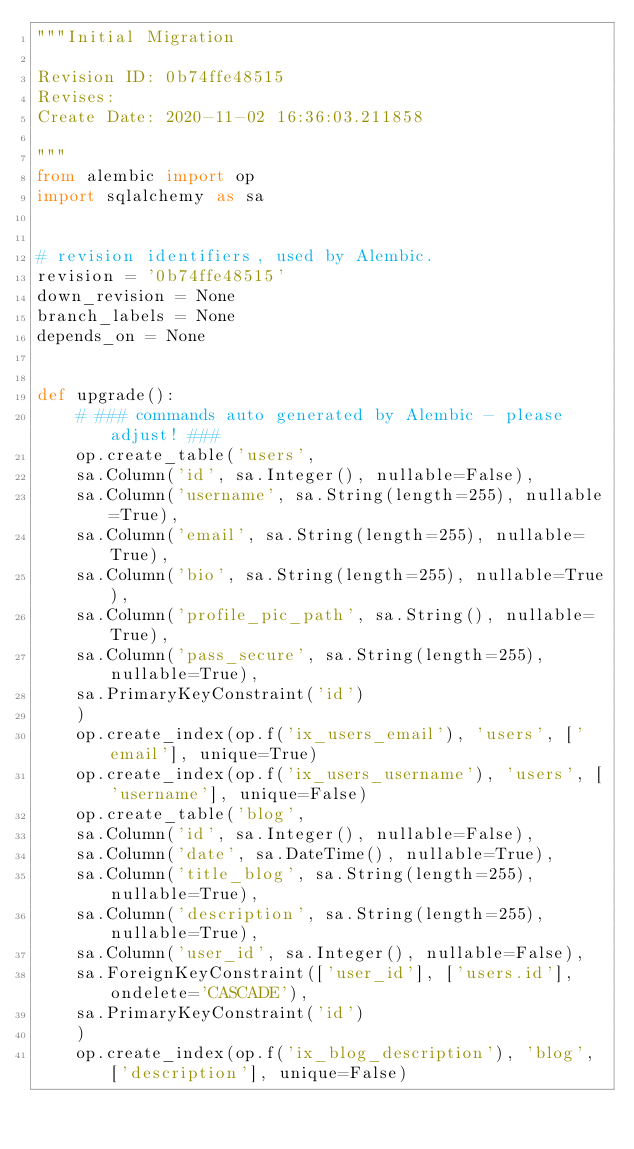<code> <loc_0><loc_0><loc_500><loc_500><_Python_>"""Initial Migration

Revision ID: 0b74ffe48515
Revises: 
Create Date: 2020-11-02 16:36:03.211858

"""
from alembic import op
import sqlalchemy as sa


# revision identifiers, used by Alembic.
revision = '0b74ffe48515'
down_revision = None
branch_labels = None
depends_on = None


def upgrade():
    # ### commands auto generated by Alembic - please adjust! ###
    op.create_table('users',
    sa.Column('id', sa.Integer(), nullable=False),
    sa.Column('username', sa.String(length=255), nullable=True),
    sa.Column('email', sa.String(length=255), nullable=True),
    sa.Column('bio', sa.String(length=255), nullable=True),
    sa.Column('profile_pic_path', sa.String(), nullable=True),
    sa.Column('pass_secure', sa.String(length=255), nullable=True),
    sa.PrimaryKeyConstraint('id')
    )
    op.create_index(op.f('ix_users_email'), 'users', ['email'], unique=True)
    op.create_index(op.f('ix_users_username'), 'users', ['username'], unique=False)
    op.create_table('blog',
    sa.Column('id', sa.Integer(), nullable=False),
    sa.Column('date', sa.DateTime(), nullable=True),
    sa.Column('title_blog', sa.String(length=255), nullable=True),
    sa.Column('description', sa.String(length=255), nullable=True),
    sa.Column('user_id', sa.Integer(), nullable=False),
    sa.ForeignKeyConstraint(['user_id'], ['users.id'], ondelete='CASCADE'),
    sa.PrimaryKeyConstraint('id')
    )
    op.create_index(op.f('ix_blog_description'), 'blog', ['description'], unique=False)</code> 